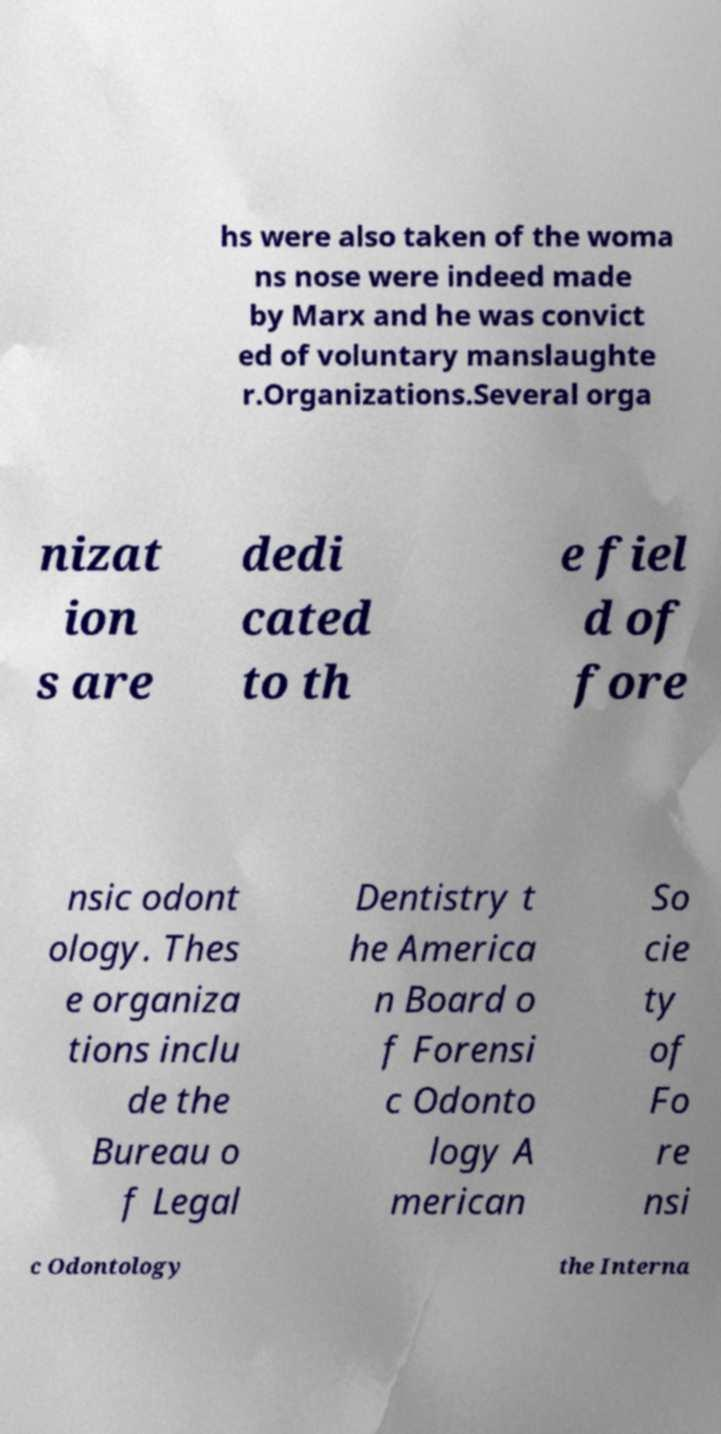What messages or text are displayed in this image? I need them in a readable, typed format. hs were also taken of the woma ns nose were indeed made by Marx and he was convict ed of voluntary manslaughte r.Organizations.Several orga nizat ion s are dedi cated to th e fiel d of fore nsic odont ology. Thes e organiza tions inclu de the Bureau o f Legal Dentistry t he America n Board o f Forensi c Odonto logy A merican So cie ty of Fo re nsi c Odontology the Interna 